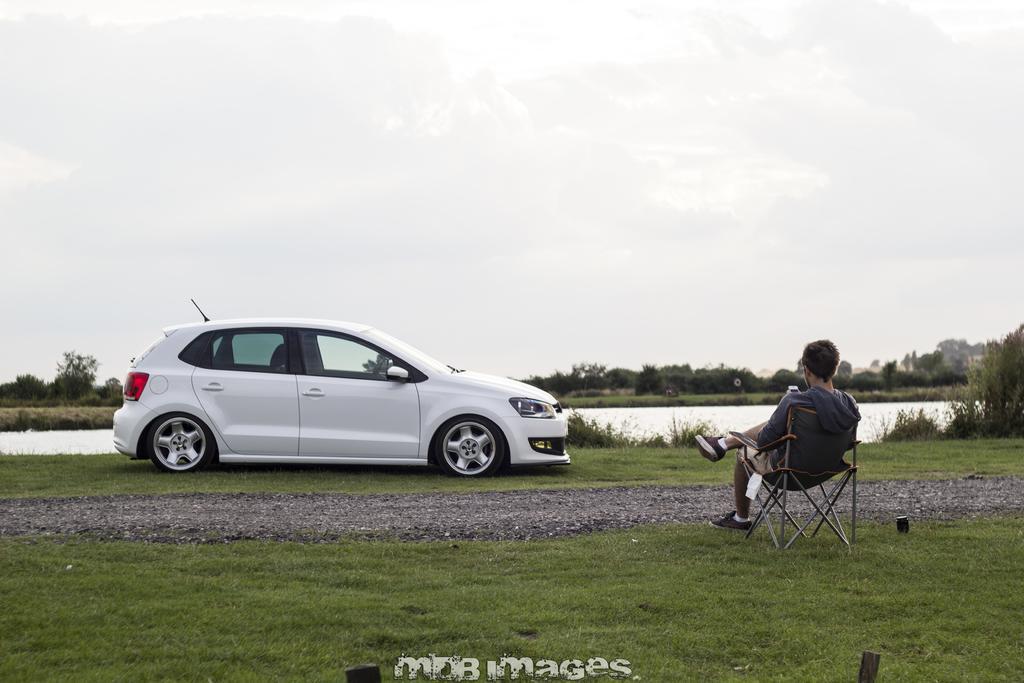Please provide a concise description of this image. There is a grass lawn with some stones. And there is a person sitting on a chair. There is a car parked near the grass lawn. In the background there is a river and sky and some trees. 